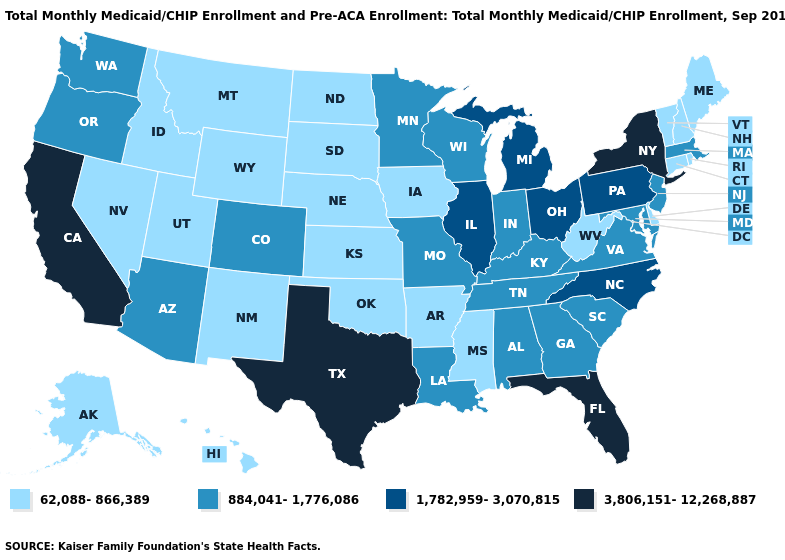Does the map have missing data?
Concise answer only. No. Does Oklahoma have a lower value than Kansas?
Give a very brief answer. No. Does North Carolina have the highest value in the USA?
Keep it brief. No. What is the highest value in states that border Maine?
Be succinct. 62,088-866,389. What is the value of West Virginia?
Keep it brief. 62,088-866,389. Does Pennsylvania have the same value as Wisconsin?
Concise answer only. No. Does Utah have a lower value than Michigan?
Write a very short answer. Yes. What is the highest value in the West ?
Concise answer only. 3,806,151-12,268,887. Does the first symbol in the legend represent the smallest category?
Concise answer only. Yes. Among the states that border Michigan , which have the highest value?
Quick response, please. Ohio. What is the value of Tennessee?
Give a very brief answer. 884,041-1,776,086. Name the states that have a value in the range 884,041-1,776,086?
Quick response, please. Alabama, Arizona, Colorado, Georgia, Indiana, Kentucky, Louisiana, Maryland, Massachusetts, Minnesota, Missouri, New Jersey, Oregon, South Carolina, Tennessee, Virginia, Washington, Wisconsin. Name the states that have a value in the range 3,806,151-12,268,887?
Quick response, please. California, Florida, New York, Texas. Does Texas have the highest value in the South?
Concise answer only. Yes. What is the value of New Jersey?
Keep it brief. 884,041-1,776,086. 